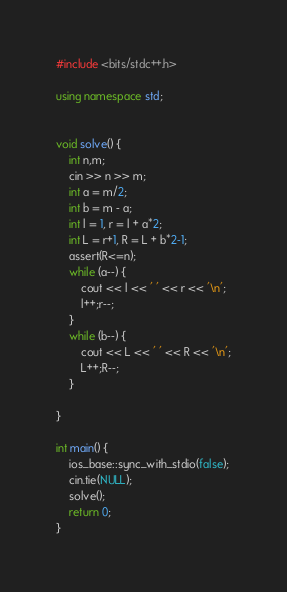Convert code to text. <code><loc_0><loc_0><loc_500><loc_500><_C++_>#include <bits/stdc++.h>

using namespace std;


void solve() {
    int n,m;
    cin >> n >> m;
    int a = m/2;
    int b = m - a;
    int l = 1, r = l + a*2;
    int L = r+1, R = L + b*2-1;
    assert(R<=n);
    while (a--) {
        cout << l << ' ' << r << '\n';
        l++;r--;
    }
    while (b--) {
        cout << L << ' ' << R << '\n';
        L++;R--;
    }
    
}

int main() {
    ios_base::sync_with_stdio(false);
    cin.tie(NULL);
    solve();
    return 0;
}
</code> 